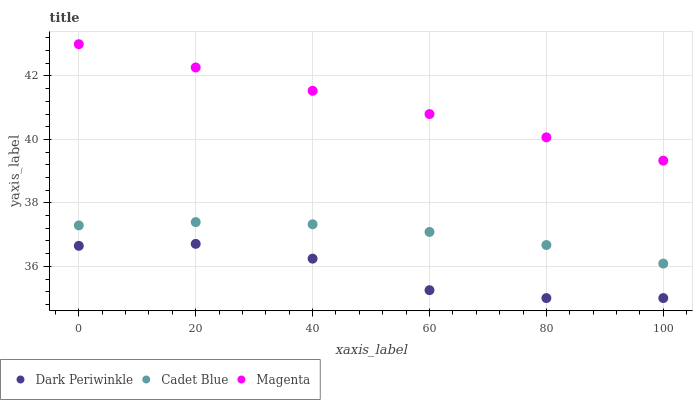Does Dark Periwinkle have the minimum area under the curve?
Answer yes or no. Yes. Does Magenta have the maximum area under the curve?
Answer yes or no. Yes. Does Cadet Blue have the minimum area under the curve?
Answer yes or no. No. Does Cadet Blue have the maximum area under the curve?
Answer yes or no. No. Is Magenta the smoothest?
Answer yes or no. Yes. Is Dark Periwinkle the roughest?
Answer yes or no. Yes. Is Cadet Blue the smoothest?
Answer yes or no. No. Is Cadet Blue the roughest?
Answer yes or no. No. Does Dark Periwinkle have the lowest value?
Answer yes or no. Yes. Does Cadet Blue have the lowest value?
Answer yes or no. No. Does Magenta have the highest value?
Answer yes or no. Yes. Does Cadet Blue have the highest value?
Answer yes or no. No. Is Dark Periwinkle less than Magenta?
Answer yes or no. Yes. Is Magenta greater than Dark Periwinkle?
Answer yes or no. Yes. Does Dark Periwinkle intersect Magenta?
Answer yes or no. No. 